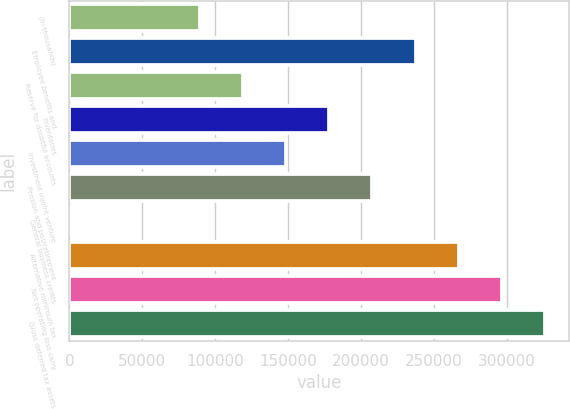<chart> <loc_0><loc_0><loc_500><loc_500><bar_chart><fcel>(In thousands)<fcel>Employee benefits and<fcel>Reserve for doubtful accounts<fcel>Inventories<fcel>Investment injoint venture<fcel>Pension and postretirement<fcel>General business credits<fcel>Alternative minimum tax<fcel>Net operating loss carry<fcel>Gross deferred tax assets<nl><fcel>89294.2<fcel>237321<fcel>118900<fcel>178110<fcel>148505<fcel>207716<fcel>478<fcel>266927<fcel>296532<fcel>326137<nl></chart> 